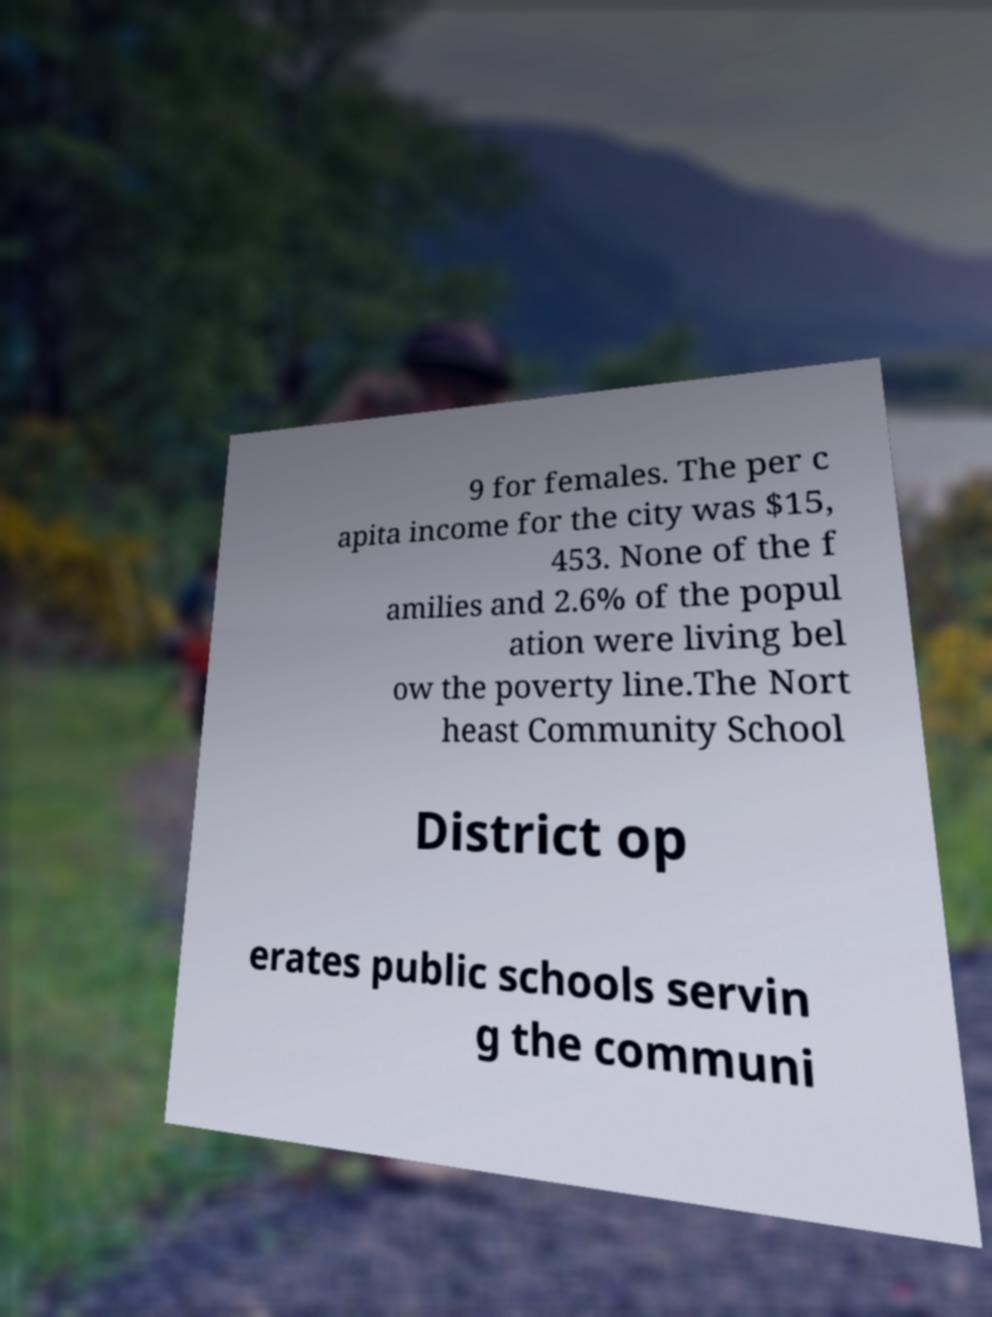Could you extract and type out the text from this image? 9 for females. The per c apita income for the city was $15, 453. None of the f amilies and 2.6% of the popul ation were living bel ow the poverty line.The Nort heast Community School District op erates public schools servin g the communi 